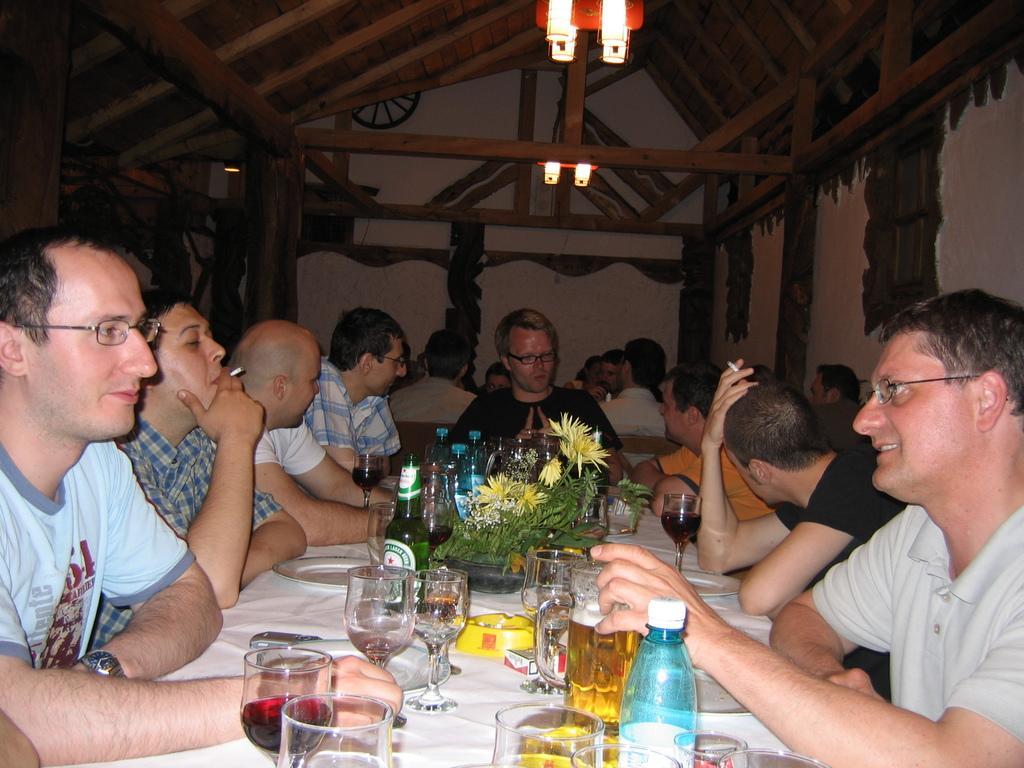Could you give a brief overview of what you see in this image? In this room every person is sitting. Lights are attached to a roof. In-front of this person there is a table. On this table there are glasses, plate, bottles and plant. Front this 2 person wore spectacles. This 2 persons hold cigar. 